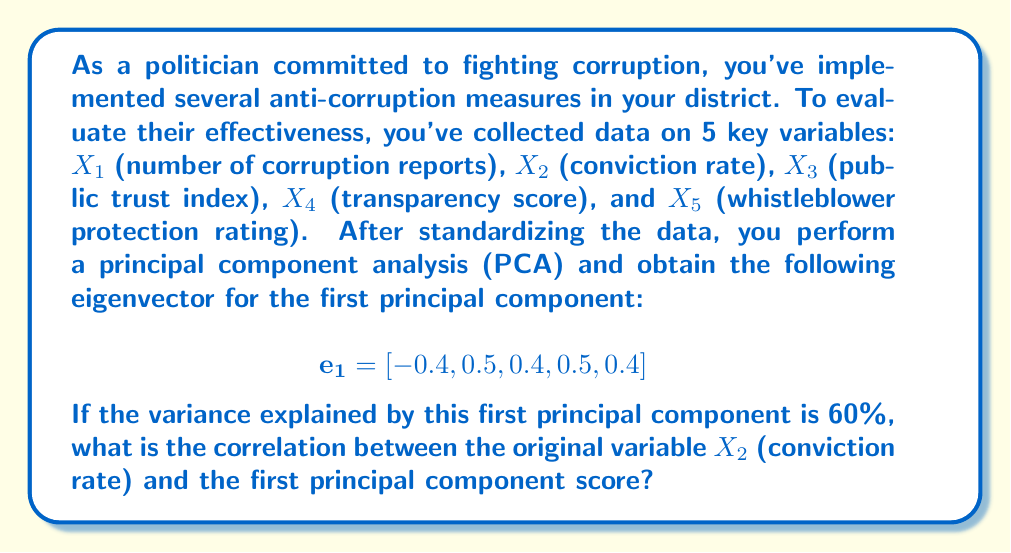Show me your answer to this math problem. To solve this problem, we'll follow these steps:

1) Recall that in PCA, the correlation between an original variable and a principal component is given by the formula:

   $$r_{X_i, PC_j} = e_{ij} \sqrt{\lambda_j}$$

   where $e_{ij}$ is the $i$-th element of the $j$-th eigenvector, and $\lambda_j$ is the $j$-th eigenvalue.

2) We're interested in the correlation between X2 and the first principal component (PC1). From the given eigenvector, we can see that $e_{21} = 0.5$.

3) We need to find $\sqrt{\lambda_1}$. We know that the variance explained by PC1 is 60%. In PCA, the proportion of variance explained by a principal component is equal to its eigenvalue divided by the number of variables:

   $$\frac{\lambda_1}{5} = 0.60$$

4) Solving for $\lambda_1$:

   $$\lambda_1 = 0.60 * 5 = 3$$

5) Now we can calculate the correlation:

   $$r_{X_2, PC_1} = e_{21} \sqrt{\lambda_1} = 0.5 * \sqrt{3} = 0.5 * 1.732 \approx 0.866$$
Answer: The correlation between the conviction rate (X2) and the first principal component score is approximately 0.866. 